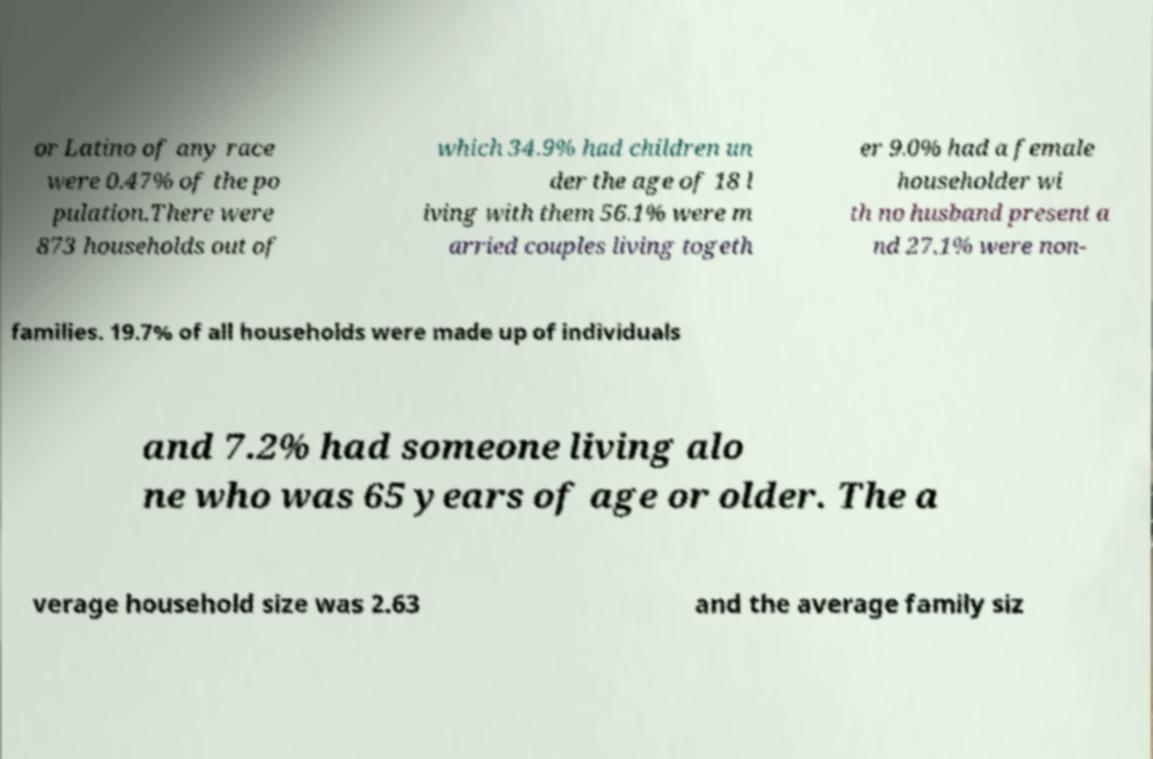Could you extract and type out the text from this image? or Latino of any race were 0.47% of the po pulation.There were 873 households out of which 34.9% had children un der the age of 18 l iving with them 56.1% were m arried couples living togeth er 9.0% had a female householder wi th no husband present a nd 27.1% were non- families. 19.7% of all households were made up of individuals and 7.2% had someone living alo ne who was 65 years of age or older. The a verage household size was 2.63 and the average family siz 